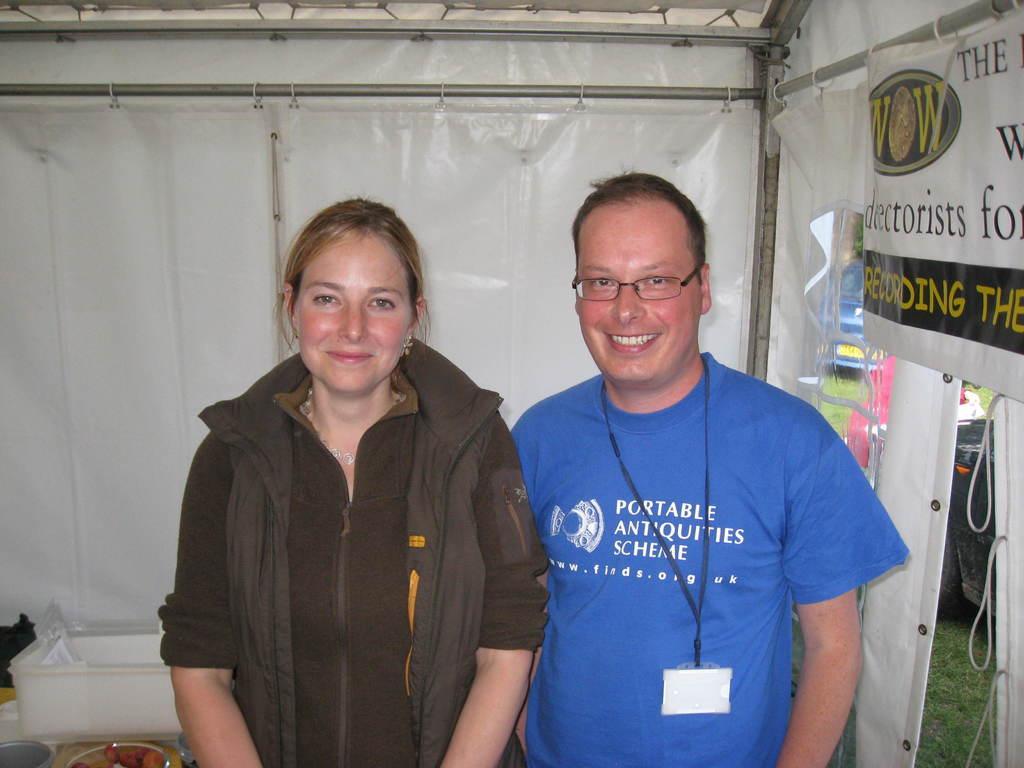How would you summarize this image in a sentence or two? In this image we can see a lady and a man, there is a poster with some text on it, there is a tent, grass, food items on the plate, there is a box. 